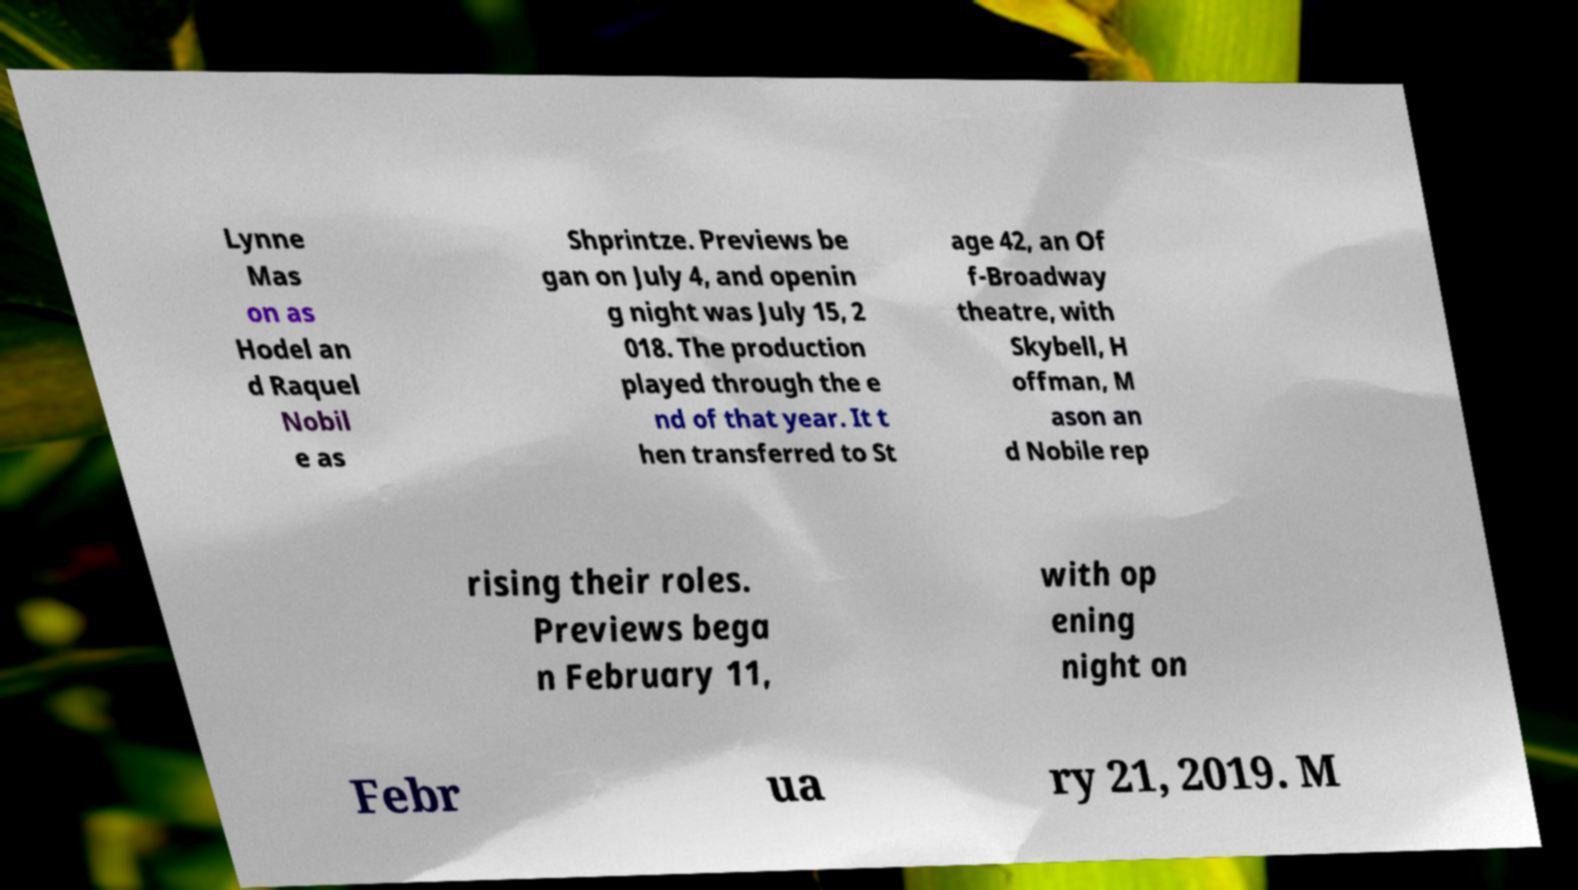What messages or text are displayed in this image? I need them in a readable, typed format. Lynne Mas on as Hodel an d Raquel Nobil e as Shprintze. Previews be gan on July 4, and openin g night was July 15, 2 018. The production played through the e nd of that year. It t hen transferred to St age 42, an Of f-Broadway theatre, with Skybell, H offman, M ason an d Nobile rep rising their roles. Previews bega n February 11, with op ening night on Febr ua ry 21, 2019. M 